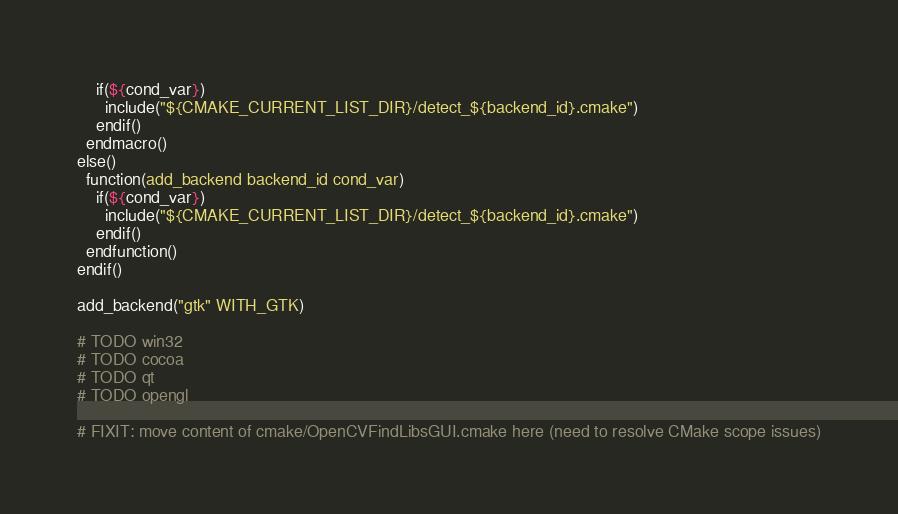<code> <loc_0><loc_0><loc_500><loc_500><_CMake_>    if(${cond_var})
      include("${CMAKE_CURRENT_LIST_DIR}/detect_${backend_id}.cmake")
    endif()
  endmacro()
else()
  function(add_backend backend_id cond_var)
    if(${cond_var})
      include("${CMAKE_CURRENT_LIST_DIR}/detect_${backend_id}.cmake")
    endif()
  endfunction()
endif()

add_backend("gtk" WITH_GTK)

# TODO win32
# TODO cocoa
# TODO qt
# TODO opengl

# FIXIT: move content of cmake/OpenCVFindLibsGUI.cmake here (need to resolve CMake scope issues)
</code> 